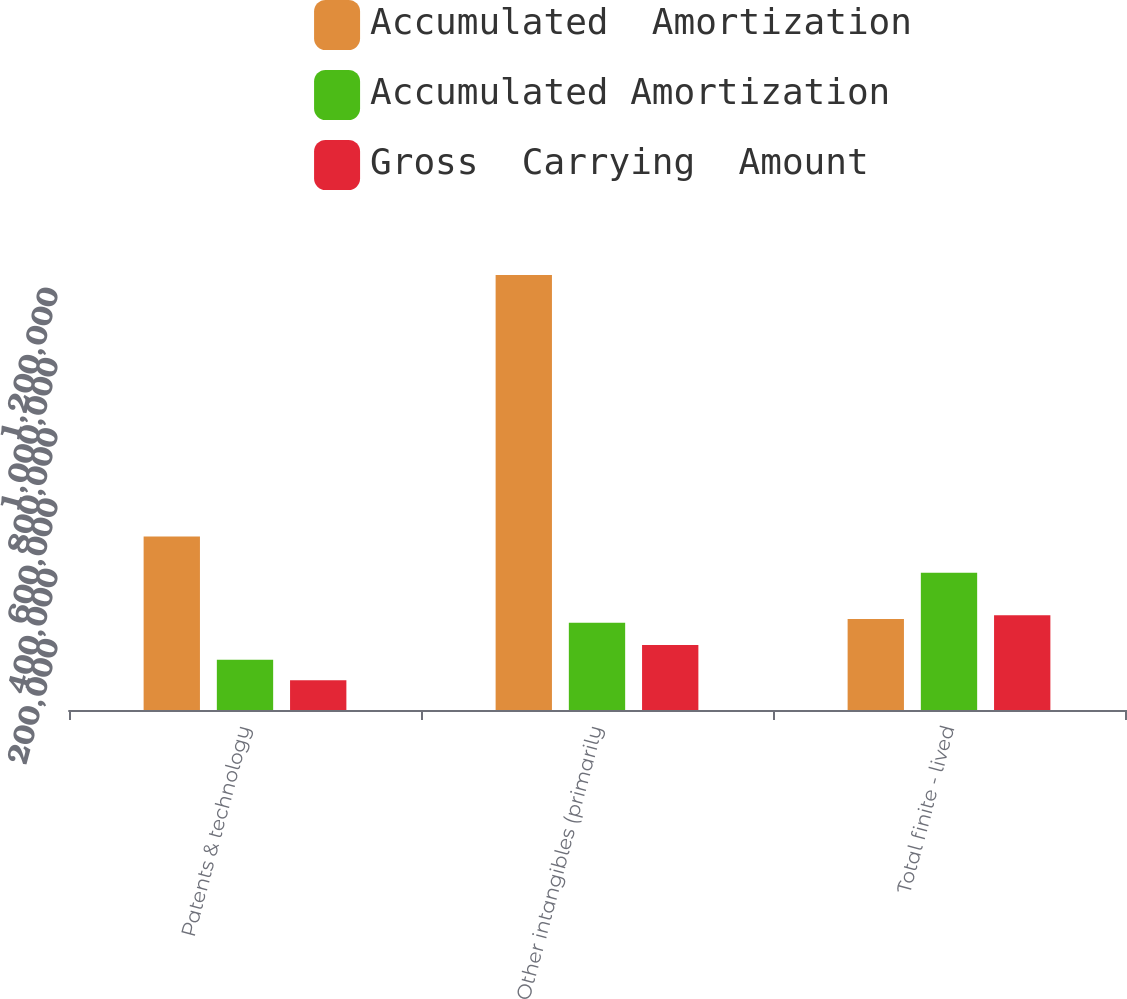<chart> <loc_0><loc_0><loc_500><loc_500><stacked_bar_chart><ecel><fcel>Patents & technology<fcel>Other intangibles (primarily<fcel>Total finite - lived<nl><fcel>Accumulated  Amortization<fcel>494047<fcel>1.2377e+06<fcel>258883<nl><fcel>Accumulated Amortization<fcel>142850<fcel>247984<fcel>390834<nl><fcel>Gross  Carrying  Amount<fcel>84669<fcel>185113<fcel>269782<nl></chart> 